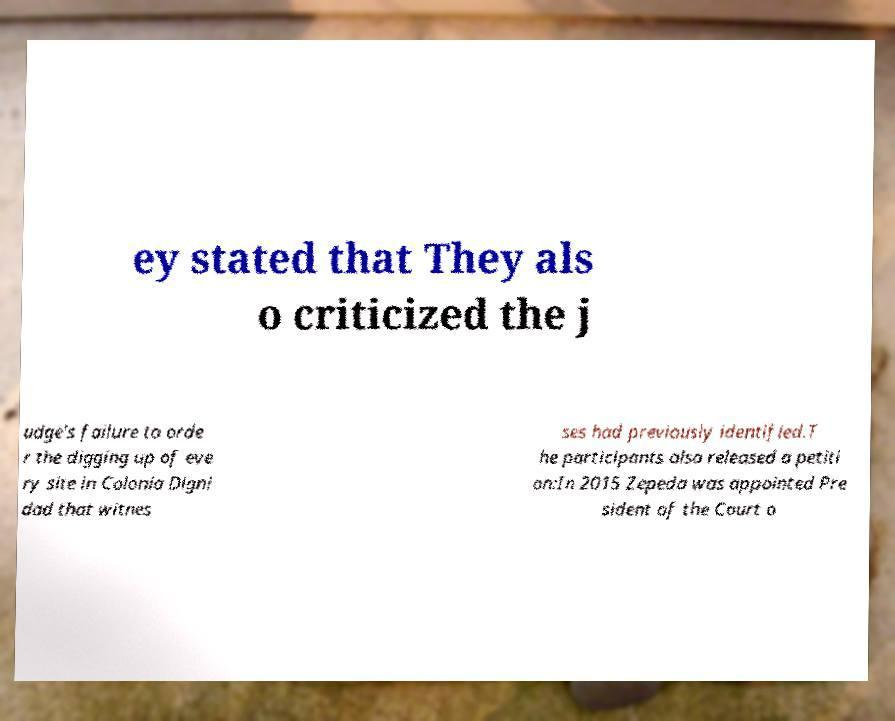Could you assist in decoding the text presented in this image and type it out clearly? ey stated that They als o criticized the j udge's failure to orde r the digging up of eve ry site in Colonia Digni dad that witnes ses had previously identified.T he participants also released a petiti on:In 2015 Zepeda was appointed Pre sident of the Court o 